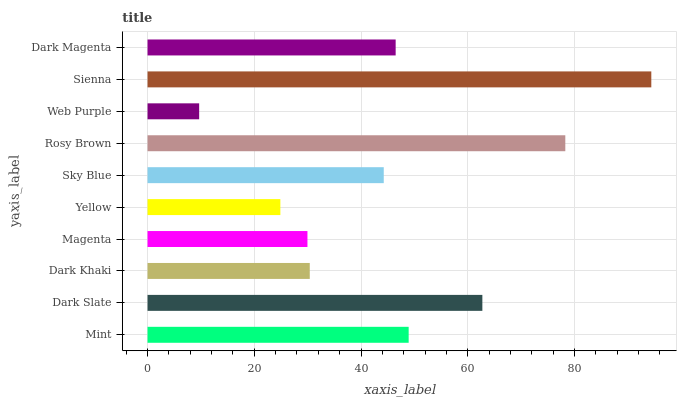Is Web Purple the minimum?
Answer yes or no. Yes. Is Sienna the maximum?
Answer yes or no. Yes. Is Dark Slate the minimum?
Answer yes or no. No. Is Dark Slate the maximum?
Answer yes or no. No. Is Dark Slate greater than Mint?
Answer yes or no. Yes. Is Mint less than Dark Slate?
Answer yes or no. Yes. Is Mint greater than Dark Slate?
Answer yes or no. No. Is Dark Slate less than Mint?
Answer yes or no. No. Is Dark Magenta the high median?
Answer yes or no. Yes. Is Sky Blue the low median?
Answer yes or no. Yes. Is Dark Slate the high median?
Answer yes or no. No. Is Web Purple the low median?
Answer yes or no. No. 